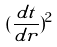Convert formula to latex. <formula><loc_0><loc_0><loc_500><loc_500>( \frac { d t } { d r } ) ^ { 2 }</formula> 